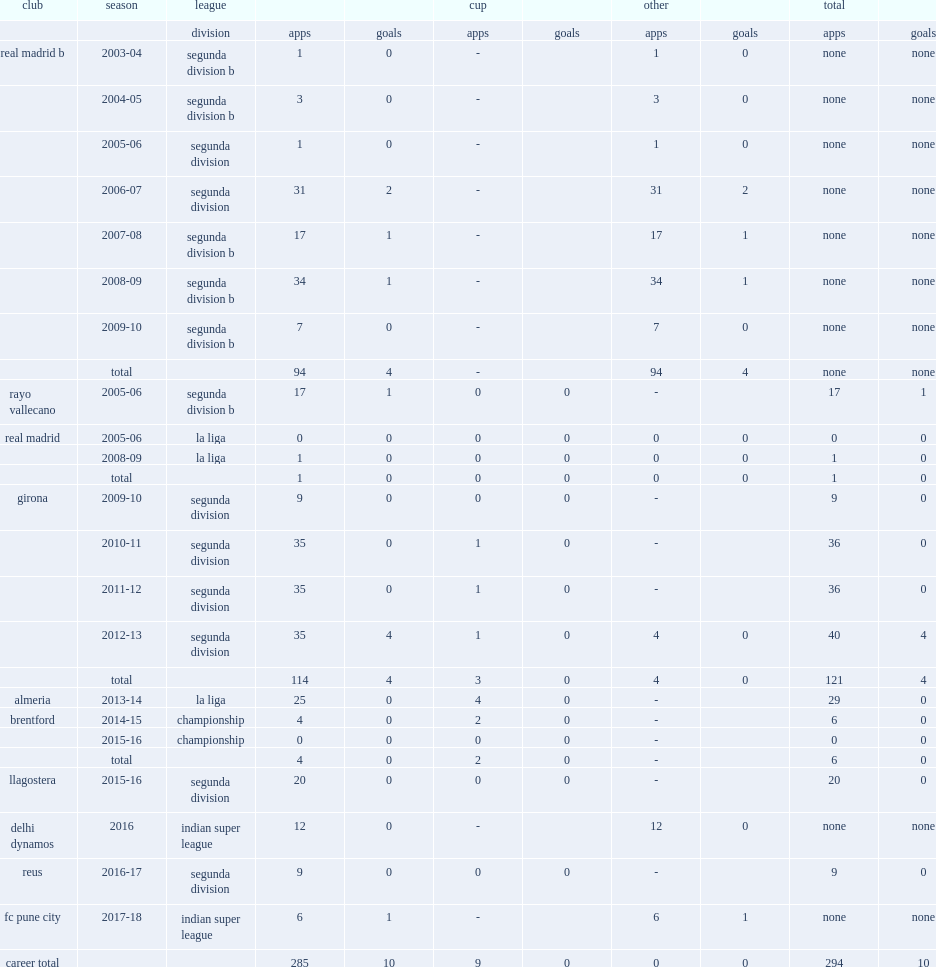In 2016, which club did tebar appear in indian super league? Delhi dynamos. 